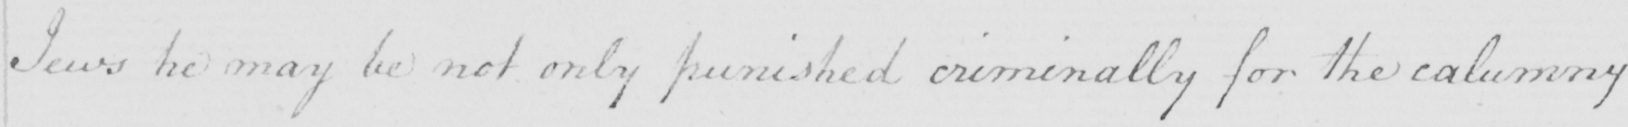What text is written in this handwritten line? Jews he may be not only punished criminally for the calumny 